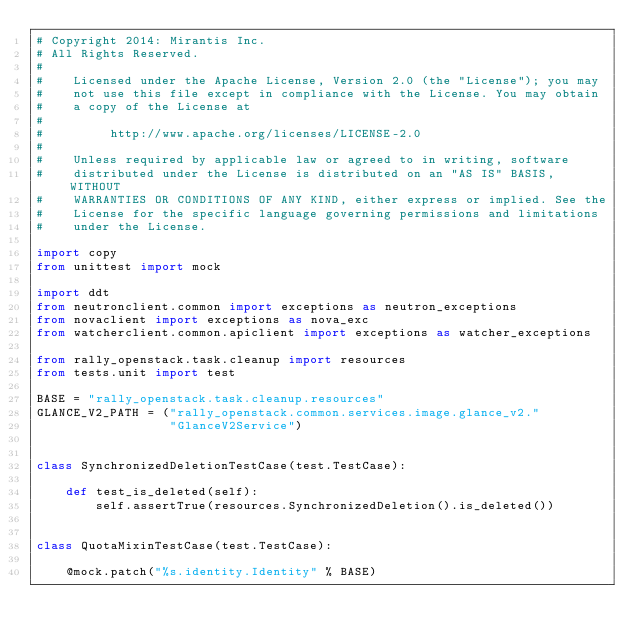Convert code to text. <code><loc_0><loc_0><loc_500><loc_500><_Python_># Copyright 2014: Mirantis Inc.
# All Rights Reserved.
#
#    Licensed under the Apache License, Version 2.0 (the "License"); you may
#    not use this file except in compliance with the License. You may obtain
#    a copy of the License at
#
#         http://www.apache.org/licenses/LICENSE-2.0
#
#    Unless required by applicable law or agreed to in writing, software
#    distributed under the License is distributed on an "AS IS" BASIS, WITHOUT
#    WARRANTIES OR CONDITIONS OF ANY KIND, either express or implied. See the
#    License for the specific language governing permissions and limitations
#    under the License.

import copy
from unittest import mock

import ddt
from neutronclient.common import exceptions as neutron_exceptions
from novaclient import exceptions as nova_exc
from watcherclient.common.apiclient import exceptions as watcher_exceptions

from rally_openstack.task.cleanup import resources
from tests.unit import test

BASE = "rally_openstack.task.cleanup.resources"
GLANCE_V2_PATH = ("rally_openstack.common.services.image.glance_v2."
                  "GlanceV2Service")


class SynchronizedDeletionTestCase(test.TestCase):

    def test_is_deleted(self):
        self.assertTrue(resources.SynchronizedDeletion().is_deleted())


class QuotaMixinTestCase(test.TestCase):

    @mock.patch("%s.identity.Identity" % BASE)</code> 